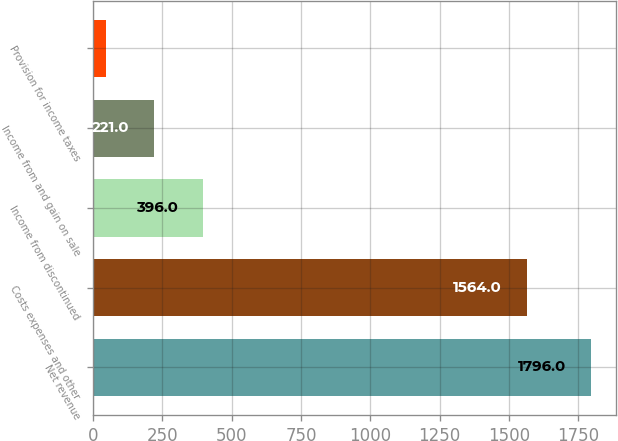Convert chart to OTSL. <chart><loc_0><loc_0><loc_500><loc_500><bar_chart><fcel>Net revenue<fcel>Costs expenses and other<fcel>Income from discontinued<fcel>Income from and gain on sale<fcel>Provision for income taxes<nl><fcel>1796<fcel>1564<fcel>396<fcel>221<fcel>46<nl></chart> 